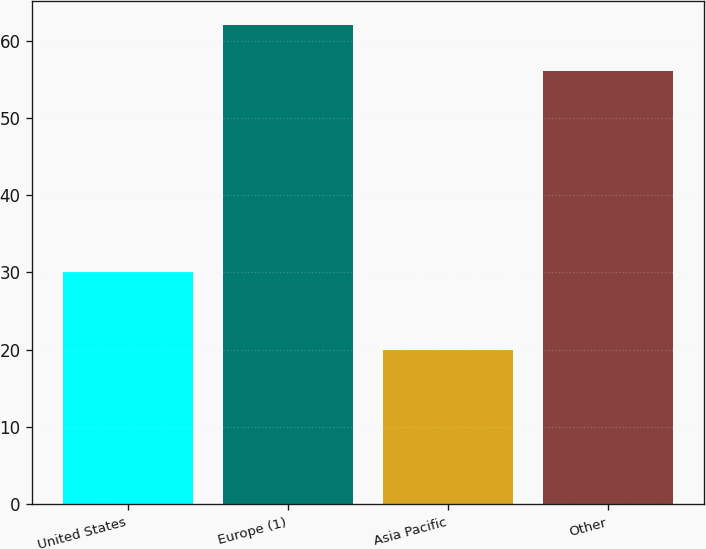<chart> <loc_0><loc_0><loc_500><loc_500><bar_chart><fcel>United States<fcel>Europe (1)<fcel>Asia Pacific<fcel>Other<nl><fcel>30<fcel>62<fcel>20<fcel>56<nl></chart> 